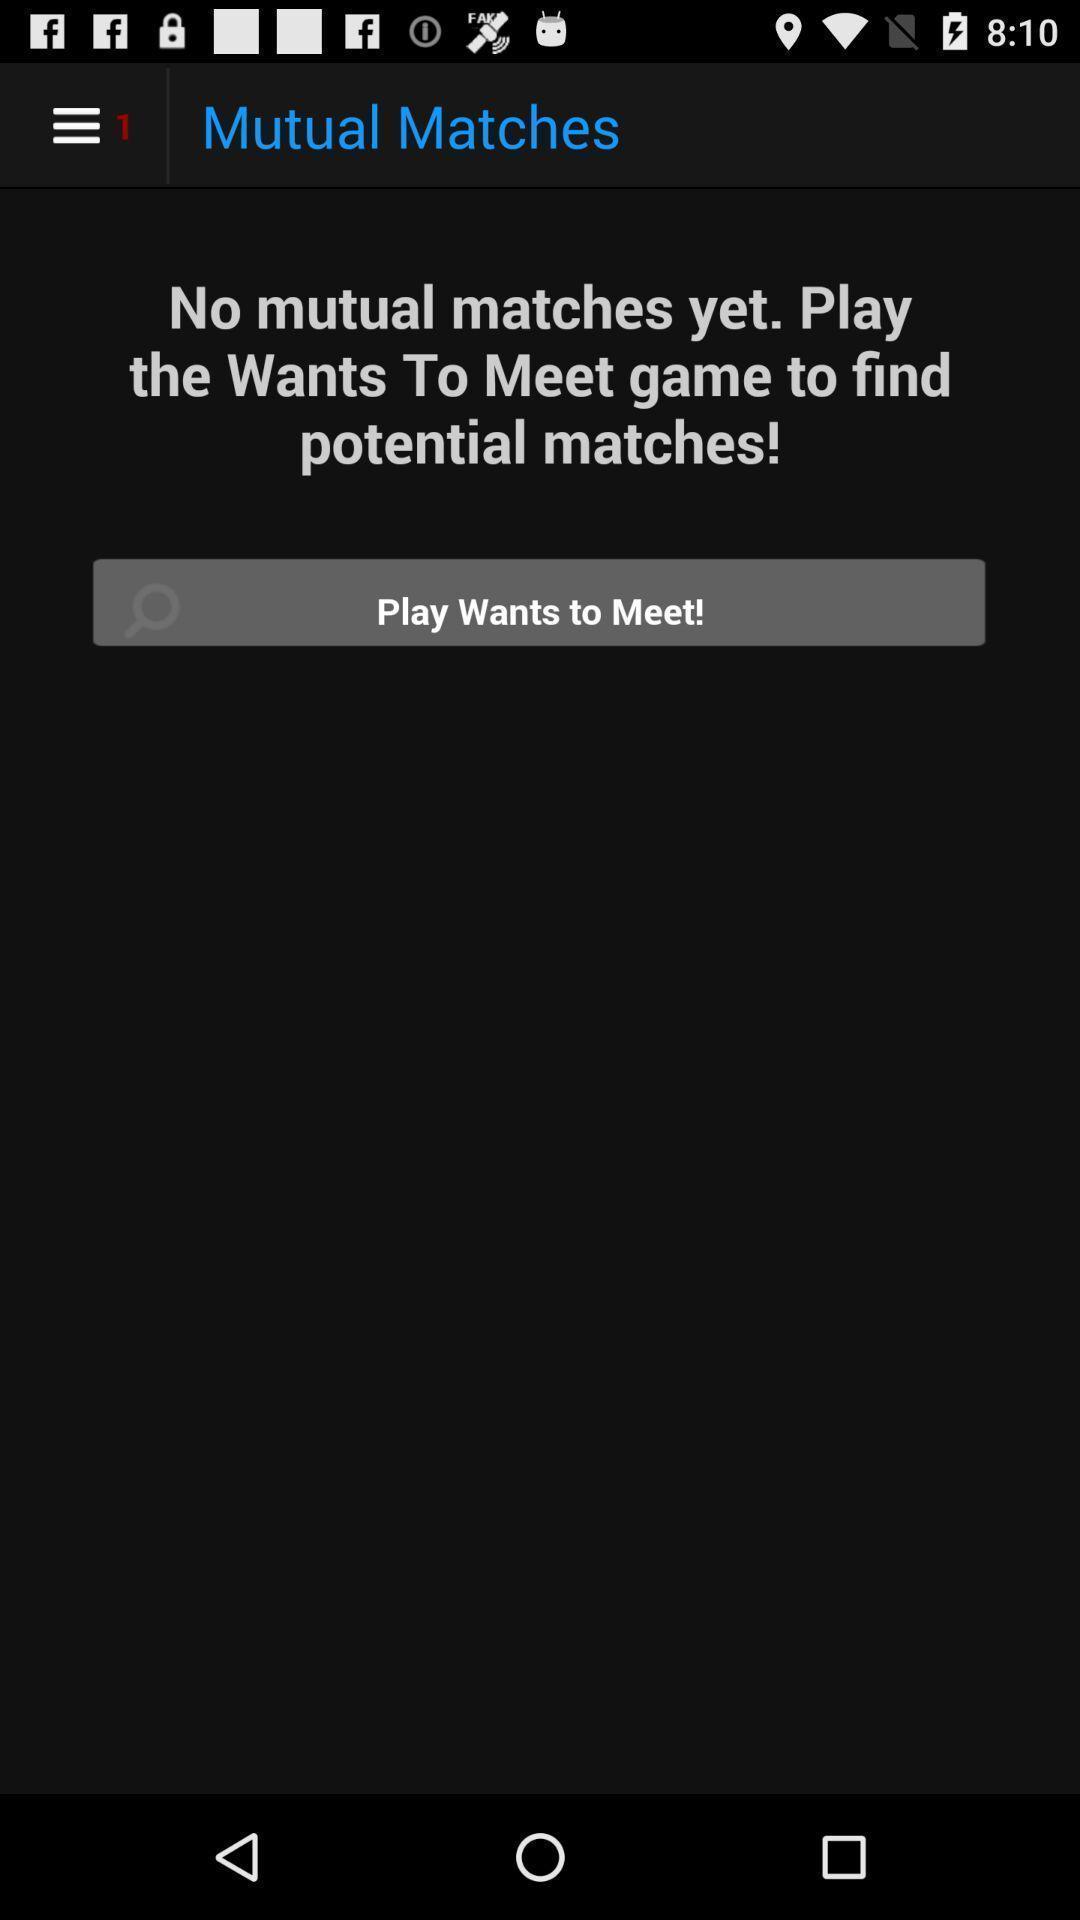What is the overall content of this screenshot? Page showing the input fields to meet people. 